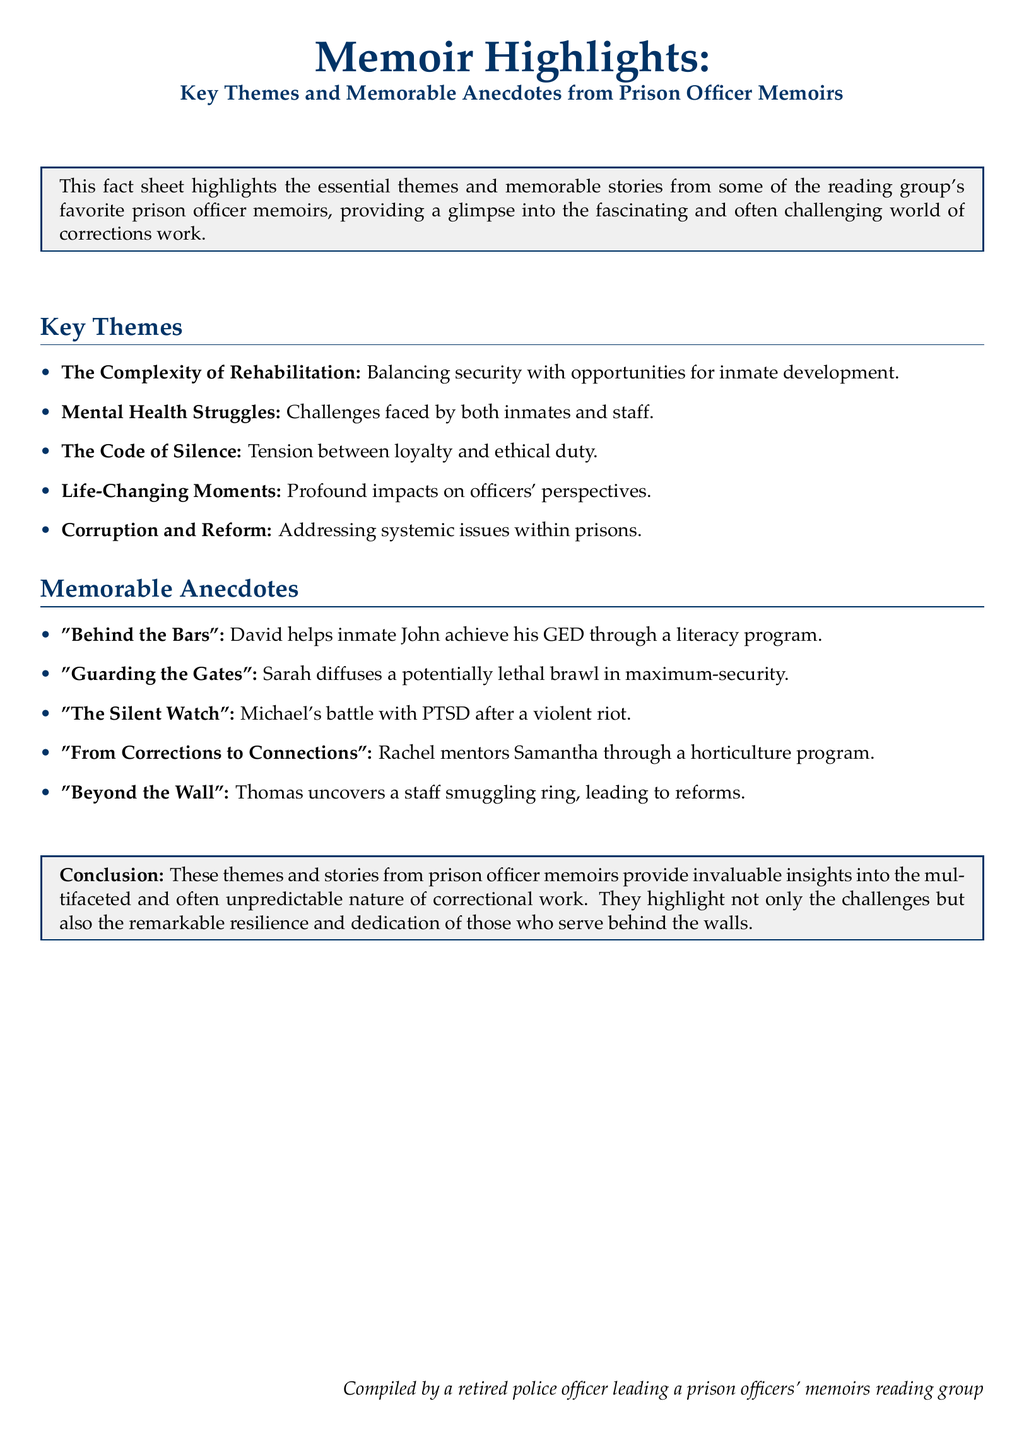What is one key theme mentioned in the document? The key theme "The Complexity of Rehabilitation" addresses the balance of security and inmate development opportunities.
Answer: The Complexity of Rehabilitation What memorable anecdote involves mentoring? "From Corrections to Connections" describes a mentor relationship formed through a horticulture program.
Answer: From Corrections to Connections How many key themes are listed in the document? The document enumerates five key themes under the section "Key Themes."
Answer: Five Who is the author of the anecdote about diffusing a brawl? The name associated with diffusing a potentially lethal brawl in maximum-security is Sarah.
Answer: Sarah What does the conclusion highlight about correctional work? The conclusion states that the memoirs provide insights into the unpredictable nature of correctional work, highlighting resilience and dedication.
Answer: Resilience and dedication What aspect of mental health does the document address? The document mentions "Mental Health Struggles" as a key theme affecting both inmates and staff.
Answer: Mental Health Struggles What significant issue does Thomas uncover? The anecdote "Beyond the Wall" details Thomas uncovering a staff smuggling ring that leads to reforms.
Answer: A staff smuggling ring What type of document is this? The document is categorized as a "Fact sheet" showcasing highlights from prison officer memoirs.
Answer: Fact sheet 